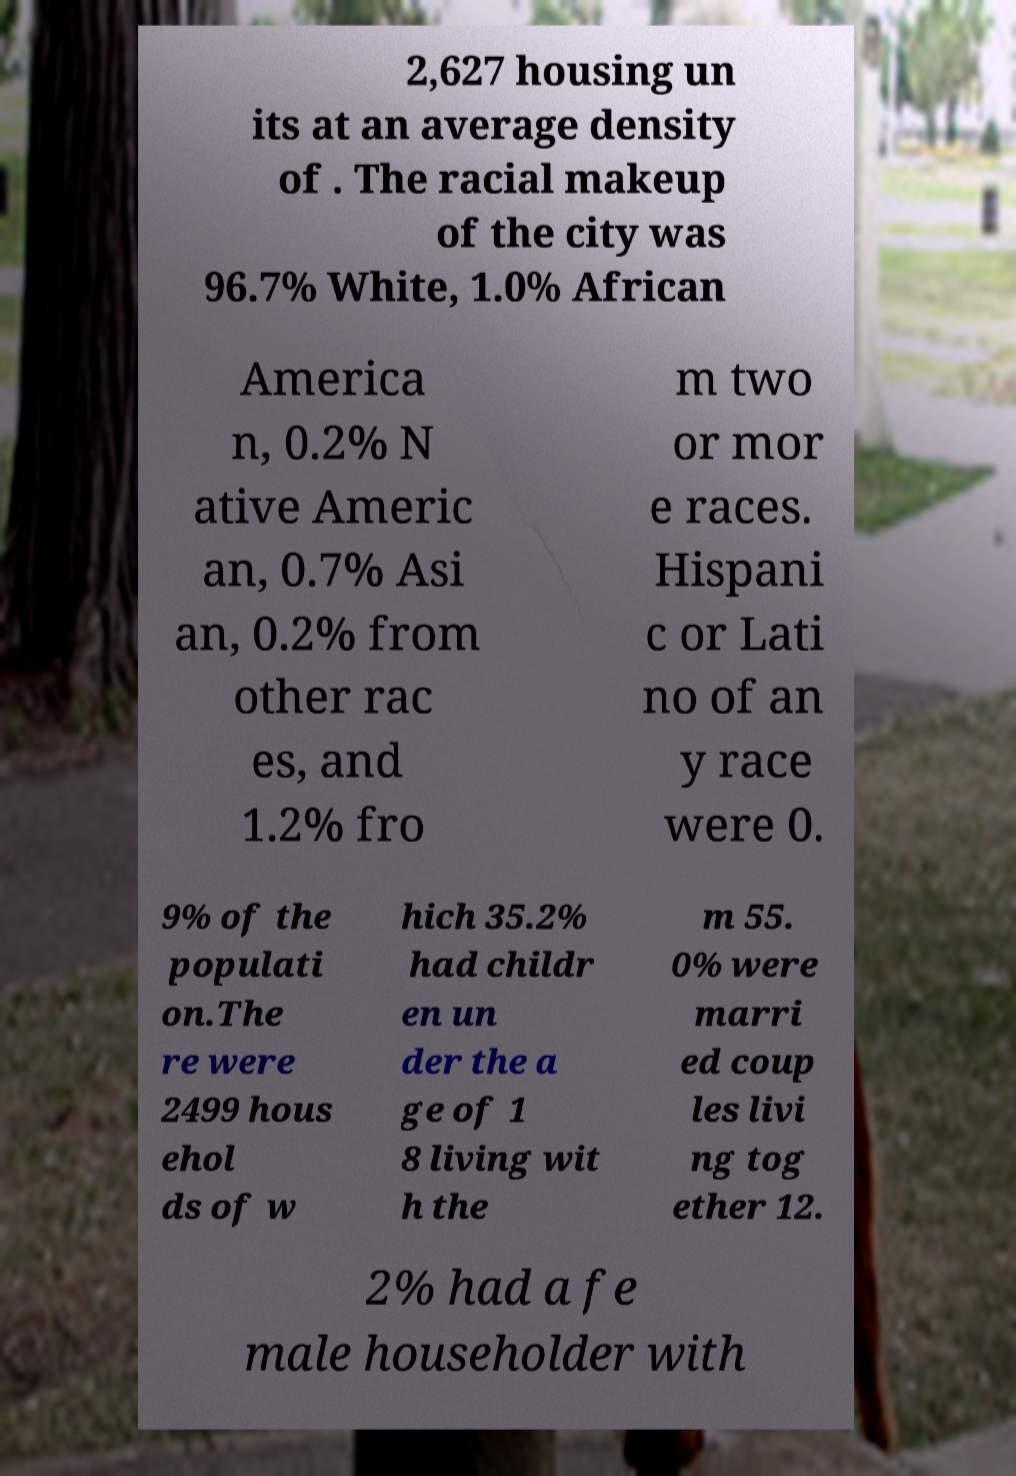Could you extract and type out the text from this image? 2,627 housing un its at an average density of . The racial makeup of the city was 96.7% White, 1.0% African America n, 0.2% N ative Americ an, 0.7% Asi an, 0.2% from other rac es, and 1.2% fro m two or mor e races. Hispani c or Lati no of an y race were 0. 9% of the populati on.The re were 2499 hous ehol ds of w hich 35.2% had childr en un der the a ge of 1 8 living wit h the m 55. 0% were marri ed coup les livi ng tog ether 12. 2% had a fe male householder with 